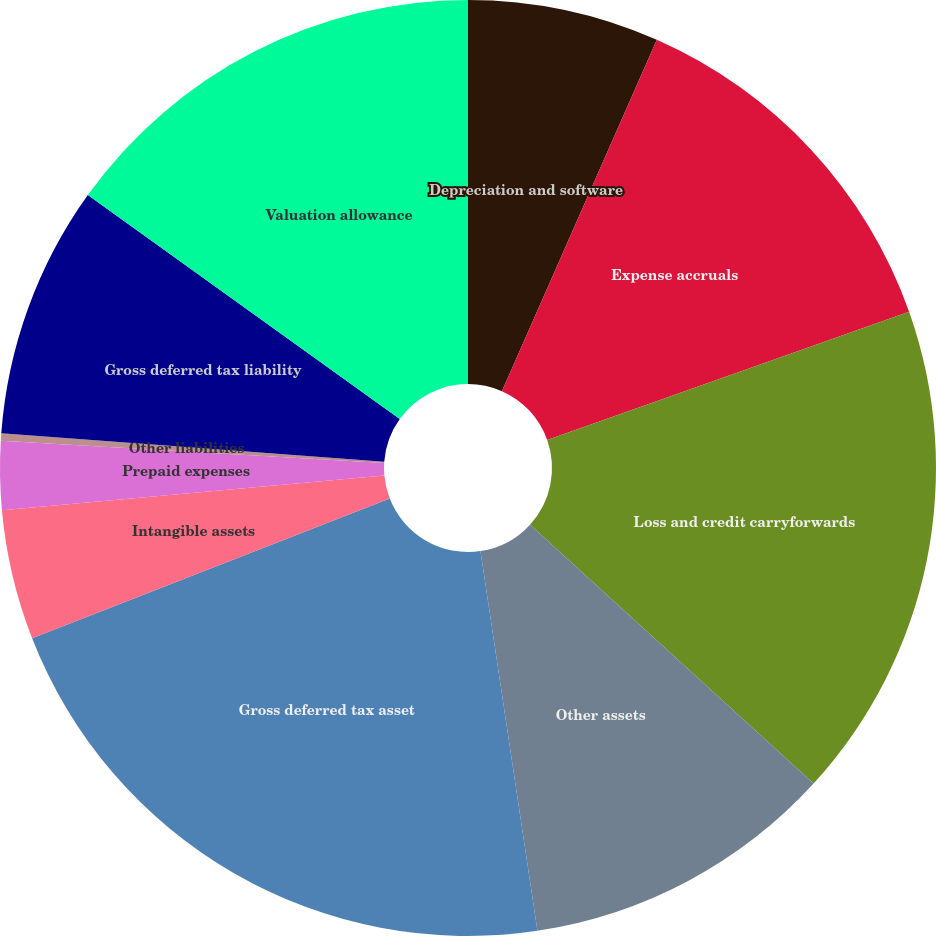Convert chart. <chart><loc_0><loc_0><loc_500><loc_500><pie_chart><fcel>Depreciation and software<fcel>Expense accruals<fcel>Loss and credit carryforwards<fcel>Other assets<fcel>Gross deferred tax asset<fcel>Intangible assets<fcel>Prepaid expenses<fcel>Other liabilities<fcel>Gross deferred tax liability<fcel>Valuation allowance<nl><fcel>6.61%<fcel>12.97%<fcel>17.2%<fcel>10.85%<fcel>21.44%<fcel>4.49%<fcel>2.37%<fcel>0.25%<fcel>8.73%<fcel>15.09%<nl></chart> 